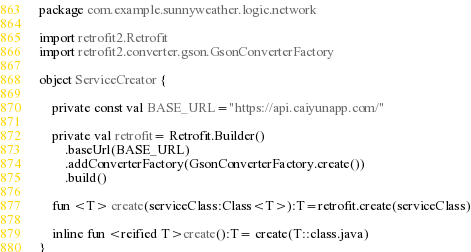<code> <loc_0><loc_0><loc_500><loc_500><_Kotlin_>package com.example.sunnyweather.logic.network

import retrofit2.Retrofit
import retrofit2.converter.gson.GsonConverterFactory

object ServiceCreator {

    private const val BASE_URL="https://api.caiyunapp.com/"

    private val retrofit= Retrofit.Builder()
        .baseUrl(BASE_URL)
        .addConverterFactory(GsonConverterFactory.create())
        .build()

    fun <T> create(serviceClass:Class<T>):T=retrofit.create(serviceClass)

    inline fun <reified T>create():T= create(T::class.java)
}</code> 